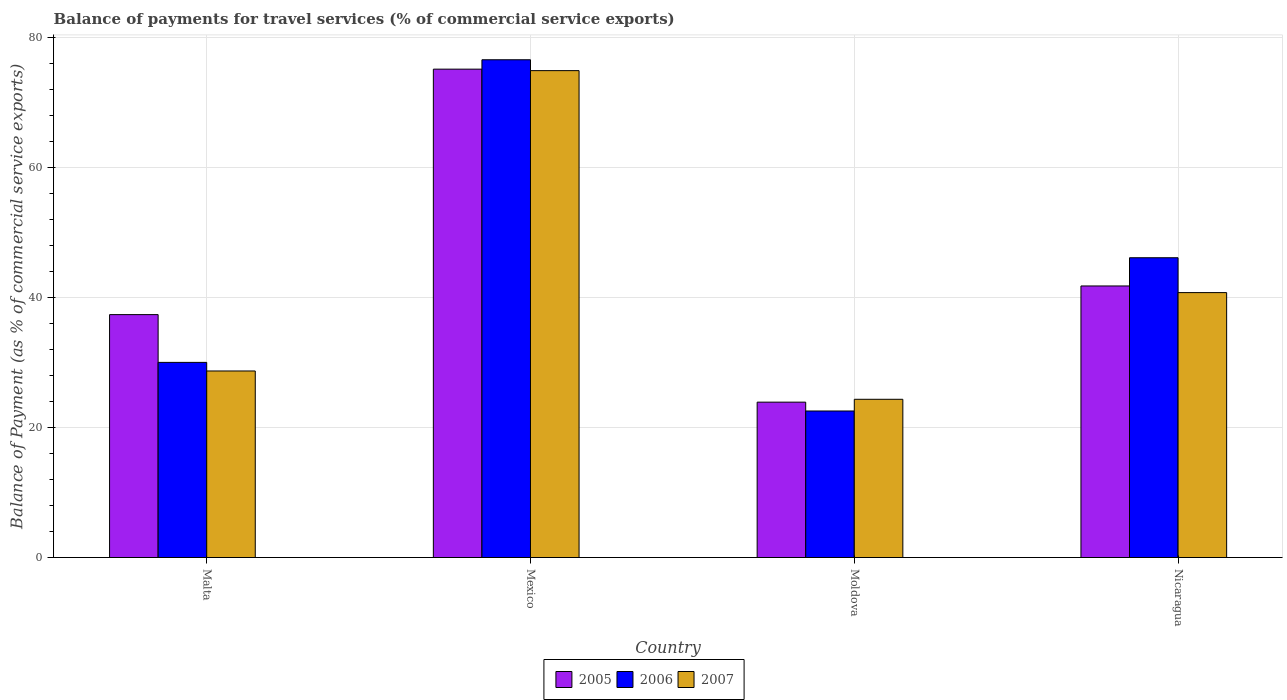How many different coloured bars are there?
Your answer should be very brief. 3. How many groups of bars are there?
Ensure brevity in your answer.  4. Are the number of bars on each tick of the X-axis equal?
Offer a very short reply. Yes. How many bars are there on the 4th tick from the right?
Give a very brief answer. 3. What is the label of the 4th group of bars from the left?
Provide a short and direct response. Nicaragua. What is the balance of payments for travel services in 2006 in Nicaragua?
Provide a succinct answer. 46.16. Across all countries, what is the maximum balance of payments for travel services in 2007?
Offer a very short reply. 74.97. Across all countries, what is the minimum balance of payments for travel services in 2005?
Ensure brevity in your answer.  23.92. In which country was the balance of payments for travel services in 2006 minimum?
Offer a terse response. Moldova. What is the total balance of payments for travel services in 2006 in the graph?
Provide a succinct answer. 175.4. What is the difference between the balance of payments for travel services in 2005 in Malta and that in Mexico?
Provide a short and direct response. -37.79. What is the difference between the balance of payments for travel services in 2005 in Mexico and the balance of payments for travel services in 2007 in Moldova?
Your response must be concise. 50.83. What is the average balance of payments for travel services in 2007 per country?
Provide a succinct answer. 42.21. What is the difference between the balance of payments for travel services of/in 2007 and balance of payments for travel services of/in 2006 in Mexico?
Offer a very short reply. -1.67. In how many countries, is the balance of payments for travel services in 2006 greater than 40 %?
Give a very brief answer. 2. What is the ratio of the balance of payments for travel services in 2005 in Mexico to that in Nicaragua?
Your answer should be compact. 1.8. Is the balance of payments for travel services in 2006 in Moldova less than that in Nicaragua?
Provide a succinct answer. Yes. Is the difference between the balance of payments for travel services in 2007 in Malta and Moldova greater than the difference between the balance of payments for travel services in 2006 in Malta and Moldova?
Provide a short and direct response. No. What is the difference between the highest and the second highest balance of payments for travel services in 2007?
Make the answer very short. -34.18. What is the difference between the highest and the lowest balance of payments for travel services in 2006?
Make the answer very short. 54.08. In how many countries, is the balance of payments for travel services in 2007 greater than the average balance of payments for travel services in 2007 taken over all countries?
Your answer should be compact. 1. What does the 1st bar from the right in Mexico represents?
Provide a succinct answer. 2007. Is it the case that in every country, the sum of the balance of payments for travel services in 2007 and balance of payments for travel services in 2006 is greater than the balance of payments for travel services in 2005?
Provide a short and direct response. Yes. How many bars are there?
Offer a terse response. 12. Are all the bars in the graph horizontal?
Provide a succinct answer. No. What is the difference between two consecutive major ticks on the Y-axis?
Your answer should be very brief. 20. Are the values on the major ticks of Y-axis written in scientific E-notation?
Keep it short and to the point. No. Does the graph contain any zero values?
Provide a short and direct response. No. Where does the legend appear in the graph?
Offer a very short reply. Bottom center. How many legend labels are there?
Your response must be concise. 3. How are the legend labels stacked?
Your answer should be compact. Horizontal. What is the title of the graph?
Make the answer very short. Balance of payments for travel services (% of commercial service exports). Does "1997" appear as one of the legend labels in the graph?
Your answer should be very brief. No. What is the label or title of the X-axis?
Offer a very short reply. Country. What is the label or title of the Y-axis?
Make the answer very short. Balance of Payment (as % of commercial service exports). What is the Balance of Payment (as % of commercial service exports) in 2005 in Malta?
Your answer should be compact. 37.4. What is the Balance of Payment (as % of commercial service exports) in 2006 in Malta?
Your answer should be very brief. 30.05. What is the Balance of Payment (as % of commercial service exports) of 2007 in Malta?
Keep it short and to the point. 28.72. What is the Balance of Payment (as % of commercial service exports) in 2005 in Mexico?
Keep it short and to the point. 75.19. What is the Balance of Payment (as % of commercial service exports) in 2006 in Mexico?
Your answer should be very brief. 76.64. What is the Balance of Payment (as % of commercial service exports) in 2007 in Mexico?
Your answer should be very brief. 74.97. What is the Balance of Payment (as % of commercial service exports) in 2005 in Moldova?
Your answer should be very brief. 23.92. What is the Balance of Payment (as % of commercial service exports) in 2006 in Moldova?
Your response must be concise. 22.56. What is the Balance of Payment (as % of commercial service exports) in 2007 in Moldova?
Keep it short and to the point. 24.36. What is the Balance of Payment (as % of commercial service exports) in 2005 in Nicaragua?
Make the answer very short. 41.81. What is the Balance of Payment (as % of commercial service exports) of 2006 in Nicaragua?
Provide a succinct answer. 46.16. What is the Balance of Payment (as % of commercial service exports) of 2007 in Nicaragua?
Ensure brevity in your answer.  40.79. Across all countries, what is the maximum Balance of Payment (as % of commercial service exports) in 2005?
Provide a short and direct response. 75.19. Across all countries, what is the maximum Balance of Payment (as % of commercial service exports) of 2006?
Your response must be concise. 76.64. Across all countries, what is the maximum Balance of Payment (as % of commercial service exports) of 2007?
Your response must be concise. 74.97. Across all countries, what is the minimum Balance of Payment (as % of commercial service exports) of 2005?
Your response must be concise. 23.92. Across all countries, what is the minimum Balance of Payment (as % of commercial service exports) in 2006?
Keep it short and to the point. 22.56. Across all countries, what is the minimum Balance of Payment (as % of commercial service exports) in 2007?
Provide a succinct answer. 24.36. What is the total Balance of Payment (as % of commercial service exports) of 2005 in the graph?
Keep it short and to the point. 178.33. What is the total Balance of Payment (as % of commercial service exports) in 2006 in the graph?
Provide a succinct answer. 175.4. What is the total Balance of Payment (as % of commercial service exports) of 2007 in the graph?
Make the answer very short. 168.84. What is the difference between the Balance of Payment (as % of commercial service exports) of 2005 in Malta and that in Mexico?
Your answer should be very brief. -37.79. What is the difference between the Balance of Payment (as % of commercial service exports) in 2006 in Malta and that in Mexico?
Your answer should be very brief. -46.59. What is the difference between the Balance of Payment (as % of commercial service exports) in 2007 in Malta and that in Mexico?
Offer a terse response. -46.24. What is the difference between the Balance of Payment (as % of commercial service exports) of 2005 in Malta and that in Moldova?
Ensure brevity in your answer.  13.48. What is the difference between the Balance of Payment (as % of commercial service exports) of 2006 in Malta and that in Moldova?
Ensure brevity in your answer.  7.48. What is the difference between the Balance of Payment (as % of commercial service exports) of 2007 in Malta and that in Moldova?
Your answer should be very brief. 4.36. What is the difference between the Balance of Payment (as % of commercial service exports) in 2005 in Malta and that in Nicaragua?
Ensure brevity in your answer.  -4.41. What is the difference between the Balance of Payment (as % of commercial service exports) of 2006 in Malta and that in Nicaragua?
Give a very brief answer. -16.11. What is the difference between the Balance of Payment (as % of commercial service exports) of 2007 in Malta and that in Nicaragua?
Offer a very short reply. -12.07. What is the difference between the Balance of Payment (as % of commercial service exports) of 2005 in Mexico and that in Moldova?
Give a very brief answer. 51.27. What is the difference between the Balance of Payment (as % of commercial service exports) in 2006 in Mexico and that in Moldova?
Give a very brief answer. 54.08. What is the difference between the Balance of Payment (as % of commercial service exports) in 2007 in Mexico and that in Moldova?
Give a very brief answer. 50.6. What is the difference between the Balance of Payment (as % of commercial service exports) of 2005 in Mexico and that in Nicaragua?
Provide a succinct answer. 33.38. What is the difference between the Balance of Payment (as % of commercial service exports) of 2006 in Mexico and that in Nicaragua?
Offer a terse response. 30.48. What is the difference between the Balance of Payment (as % of commercial service exports) in 2007 in Mexico and that in Nicaragua?
Give a very brief answer. 34.18. What is the difference between the Balance of Payment (as % of commercial service exports) in 2005 in Moldova and that in Nicaragua?
Provide a succinct answer. -17.89. What is the difference between the Balance of Payment (as % of commercial service exports) of 2006 in Moldova and that in Nicaragua?
Your answer should be very brief. -23.59. What is the difference between the Balance of Payment (as % of commercial service exports) in 2007 in Moldova and that in Nicaragua?
Offer a terse response. -16.43. What is the difference between the Balance of Payment (as % of commercial service exports) in 2005 in Malta and the Balance of Payment (as % of commercial service exports) in 2006 in Mexico?
Give a very brief answer. -39.24. What is the difference between the Balance of Payment (as % of commercial service exports) of 2005 in Malta and the Balance of Payment (as % of commercial service exports) of 2007 in Mexico?
Give a very brief answer. -37.57. What is the difference between the Balance of Payment (as % of commercial service exports) in 2006 in Malta and the Balance of Payment (as % of commercial service exports) in 2007 in Mexico?
Give a very brief answer. -44.92. What is the difference between the Balance of Payment (as % of commercial service exports) in 2005 in Malta and the Balance of Payment (as % of commercial service exports) in 2006 in Moldova?
Give a very brief answer. 14.84. What is the difference between the Balance of Payment (as % of commercial service exports) in 2005 in Malta and the Balance of Payment (as % of commercial service exports) in 2007 in Moldova?
Your answer should be very brief. 13.04. What is the difference between the Balance of Payment (as % of commercial service exports) in 2006 in Malta and the Balance of Payment (as % of commercial service exports) in 2007 in Moldova?
Provide a short and direct response. 5.68. What is the difference between the Balance of Payment (as % of commercial service exports) in 2005 in Malta and the Balance of Payment (as % of commercial service exports) in 2006 in Nicaragua?
Keep it short and to the point. -8.76. What is the difference between the Balance of Payment (as % of commercial service exports) of 2005 in Malta and the Balance of Payment (as % of commercial service exports) of 2007 in Nicaragua?
Provide a short and direct response. -3.39. What is the difference between the Balance of Payment (as % of commercial service exports) of 2006 in Malta and the Balance of Payment (as % of commercial service exports) of 2007 in Nicaragua?
Keep it short and to the point. -10.74. What is the difference between the Balance of Payment (as % of commercial service exports) in 2005 in Mexico and the Balance of Payment (as % of commercial service exports) in 2006 in Moldova?
Your response must be concise. 52.63. What is the difference between the Balance of Payment (as % of commercial service exports) of 2005 in Mexico and the Balance of Payment (as % of commercial service exports) of 2007 in Moldova?
Give a very brief answer. 50.83. What is the difference between the Balance of Payment (as % of commercial service exports) of 2006 in Mexico and the Balance of Payment (as % of commercial service exports) of 2007 in Moldova?
Offer a terse response. 52.28. What is the difference between the Balance of Payment (as % of commercial service exports) in 2005 in Mexico and the Balance of Payment (as % of commercial service exports) in 2006 in Nicaragua?
Your response must be concise. 29.04. What is the difference between the Balance of Payment (as % of commercial service exports) of 2005 in Mexico and the Balance of Payment (as % of commercial service exports) of 2007 in Nicaragua?
Your answer should be compact. 34.4. What is the difference between the Balance of Payment (as % of commercial service exports) in 2006 in Mexico and the Balance of Payment (as % of commercial service exports) in 2007 in Nicaragua?
Give a very brief answer. 35.85. What is the difference between the Balance of Payment (as % of commercial service exports) in 2005 in Moldova and the Balance of Payment (as % of commercial service exports) in 2006 in Nicaragua?
Offer a terse response. -22.23. What is the difference between the Balance of Payment (as % of commercial service exports) in 2005 in Moldova and the Balance of Payment (as % of commercial service exports) in 2007 in Nicaragua?
Provide a succinct answer. -16.87. What is the difference between the Balance of Payment (as % of commercial service exports) of 2006 in Moldova and the Balance of Payment (as % of commercial service exports) of 2007 in Nicaragua?
Your answer should be very brief. -18.23. What is the average Balance of Payment (as % of commercial service exports) of 2005 per country?
Provide a succinct answer. 44.58. What is the average Balance of Payment (as % of commercial service exports) in 2006 per country?
Make the answer very short. 43.85. What is the average Balance of Payment (as % of commercial service exports) of 2007 per country?
Keep it short and to the point. 42.21. What is the difference between the Balance of Payment (as % of commercial service exports) in 2005 and Balance of Payment (as % of commercial service exports) in 2006 in Malta?
Your response must be concise. 7.35. What is the difference between the Balance of Payment (as % of commercial service exports) of 2005 and Balance of Payment (as % of commercial service exports) of 2007 in Malta?
Ensure brevity in your answer.  8.68. What is the difference between the Balance of Payment (as % of commercial service exports) in 2006 and Balance of Payment (as % of commercial service exports) in 2007 in Malta?
Your answer should be compact. 1.32. What is the difference between the Balance of Payment (as % of commercial service exports) of 2005 and Balance of Payment (as % of commercial service exports) of 2006 in Mexico?
Offer a very short reply. -1.45. What is the difference between the Balance of Payment (as % of commercial service exports) of 2005 and Balance of Payment (as % of commercial service exports) of 2007 in Mexico?
Provide a succinct answer. 0.23. What is the difference between the Balance of Payment (as % of commercial service exports) of 2006 and Balance of Payment (as % of commercial service exports) of 2007 in Mexico?
Your answer should be very brief. 1.67. What is the difference between the Balance of Payment (as % of commercial service exports) in 2005 and Balance of Payment (as % of commercial service exports) in 2006 in Moldova?
Offer a terse response. 1.36. What is the difference between the Balance of Payment (as % of commercial service exports) in 2005 and Balance of Payment (as % of commercial service exports) in 2007 in Moldova?
Your answer should be very brief. -0.44. What is the difference between the Balance of Payment (as % of commercial service exports) of 2006 and Balance of Payment (as % of commercial service exports) of 2007 in Moldova?
Your answer should be compact. -1.8. What is the difference between the Balance of Payment (as % of commercial service exports) of 2005 and Balance of Payment (as % of commercial service exports) of 2006 in Nicaragua?
Provide a succinct answer. -4.34. What is the difference between the Balance of Payment (as % of commercial service exports) in 2006 and Balance of Payment (as % of commercial service exports) in 2007 in Nicaragua?
Offer a very short reply. 5.37. What is the ratio of the Balance of Payment (as % of commercial service exports) in 2005 in Malta to that in Mexico?
Offer a very short reply. 0.5. What is the ratio of the Balance of Payment (as % of commercial service exports) in 2006 in Malta to that in Mexico?
Your answer should be compact. 0.39. What is the ratio of the Balance of Payment (as % of commercial service exports) in 2007 in Malta to that in Mexico?
Give a very brief answer. 0.38. What is the ratio of the Balance of Payment (as % of commercial service exports) in 2005 in Malta to that in Moldova?
Provide a succinct answer. 1.56. What is the ratio of the Balance of Payment (as % of commercial service exports) of 2006 in Malta to that in Moldova?
Give a very brief answer. 1.33. What is the ratio of the Balance of Payment (as % of commercial service exports) of 2007 in Malta to that in Moldova?
Offer a terse response. 1.18. What is the ratio of the Balance of Payment (as % of commercial service exports) of 2005 in Malta to that in Nicaragua?
Provide a succinct answer. 0.89. What is the ratio of the Balance of Payment (as % of commercial service exports) in 2006 in Malta to that in Nicaragua?
Provide a succinct answer. 0.65. What is the ratio of the Balance of Payment (as % of commercial service exports) in 2007 in Malta to that in Nicaragua?
Your answer should be very brief. 0.7. What is the ratio of the Balance of Payment (as % of commercial service exports) of 2005 in Mexico to that in Moldova?
Offer a terse response. 3.14. What is the ratio of the Balance of Payment (as % of commercial service exports) in 2006 in Mexico to that in Moldova?
Ensure brevity in your answer.  3.4. What is the ratio of the Balance of Payment (as % of commercial service exports) of 2007 in Mexico to that in Moldova?
Your response must be concise. 3.08. What is the ratio of the Balance of Payment (as % of commercial service exports) of 2005 in Mexico to that in Nicaragua?
Make the answer very short. 1.8. What is the ratio of the Balance of Payment (as % of commercial service exports) of 2006 in Mexico to that in Nicaragua?
Provide a short and direct response. 1.66. What is the ratio of the Balance of Payment (as % of commercial service exports) in 2007 in Mexico to that in Nicaragua?
Keep it short and to the point. 1.84. What is the ratio of the Balance of Payment (as % of commercial service exports) in 2005 in Moldova to that in Nicaragua?
Your response must be concise. 0.57. What is the ratio of the Balance of Payment (as % of commercial service exports) of 2006 in Moldova to that in Nicaragua?
Give a very brief answer. 0.49. What is the ratio of the Balance of Payment (as % of commercial service exports) of 2007 in Moldova to that in Nicaragua?
Your answer should be compact. 0.6. What is the difference between the highest and the second highest Balance of Payment (as % of commercial service exports) in 2005?
Keep it short and to the point. 33.38. What is the difference between the highest and the second highest Balance of Payment (as % of commercial service exports) in 2006?
Your response must be concise. 30.48. What is the difference between the highest and the second highest Balance of Payment (as % of commercial service exports) in 2007?
Keep it short and to the point. 34.18. What is the difference between the highest and the lowest Balance of Payment (as % of commercial service exports) of 2005?
Your response must be concise. 51.27. What is the difference between the highest and the lowest Balance of Payment (as % of commercial service exports) in 2006?
Keep it short and to the point. 54.08. What is the difference between the highest and the lowest Balance of Payment (as % of commercial service exports) in 2007?
Offer a terse response. 50.6. 